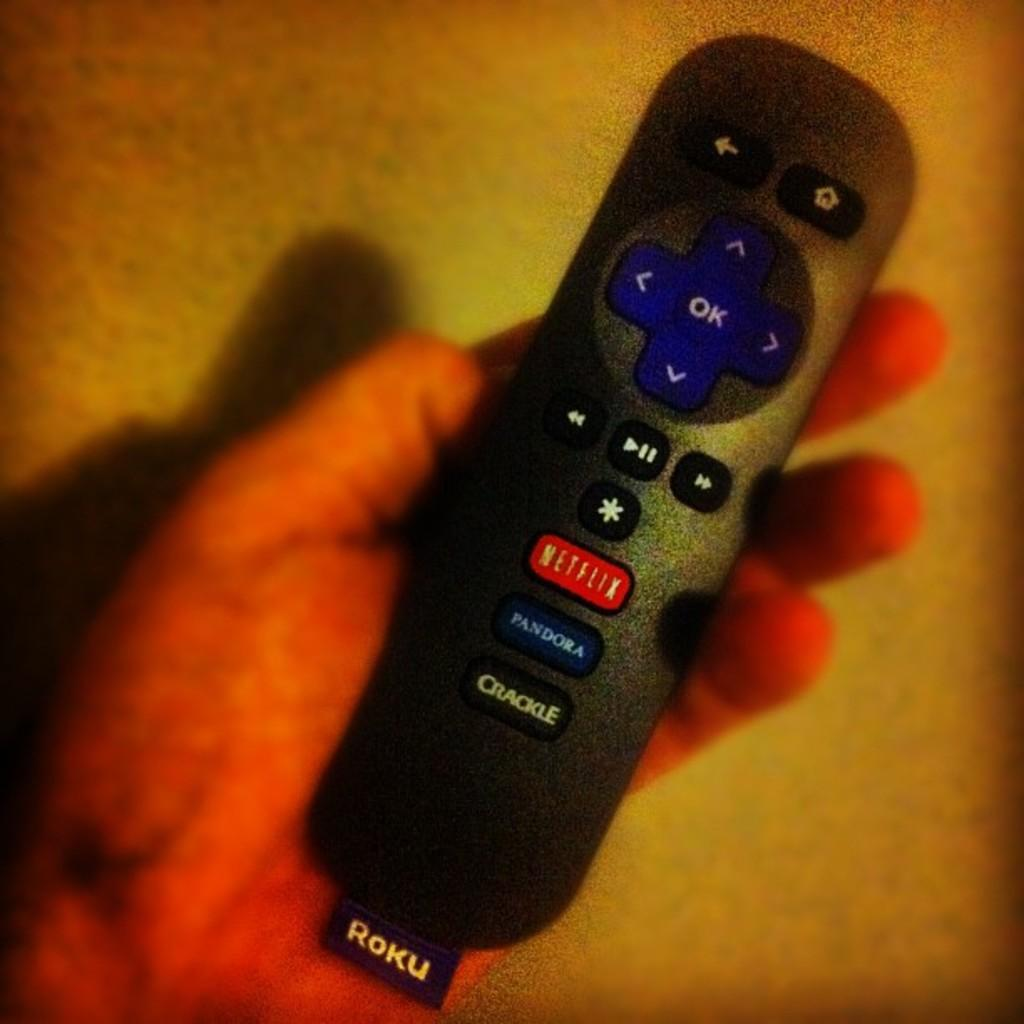<image>
Render a clear and concise summary of the photo. A hand holding a black Roku remote control. 